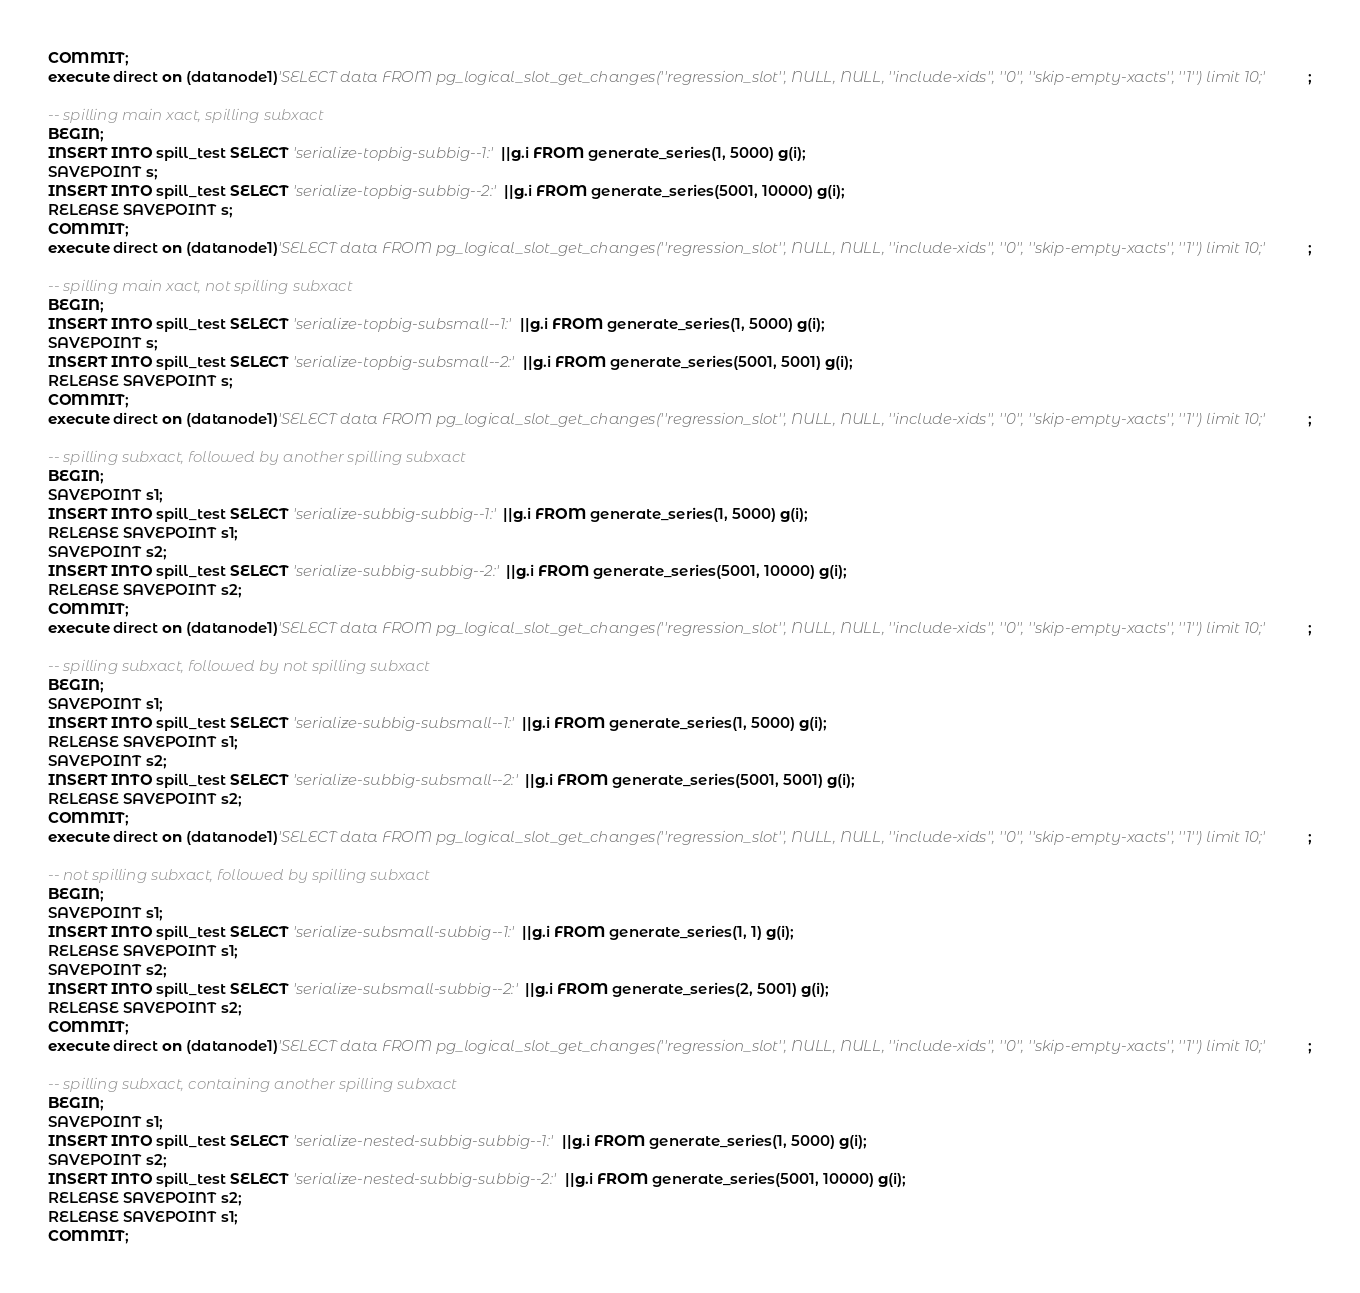Convert code to text. <code><loc_0><loc_0><loc_500><loc_500><_SQL_>COMMIT;
execute direct on (datanode1)'SELECT data FROM pg_logical_slot_get_changes(''regression_slot'', NULL, NULL, ''include-xids'', ''0'', ''skip-empty-xacts'', ''1'') limit 10;';

-- spilling main xact, spilling subxact
BEGIN;
INSERT INTO spill_test SELECT 'serialize-topbig-subbig--1:'||g.i FROM generate_series(1, 5000) g(i);
SAVEPOINT s;
INSERT INTO spill_test SELECT 'serialize-topbig-subbig--2:'||g.i FROM generate_series(5001, 10000) g(i);
RELEASE SAVEPOINT s;
COMMIT;
execute direct on (datanode1)'SELECT data FROM pg_logical_slot_get_changes(''regression_slot'', NULL, NULL, ''include-xids'', ''0'', ''skip-empty-xacts'', ''1'') limit 10;';

-- spilling main xact, not spilling subxact
BEGIN;
INSERT INTO spill_test SELECT 'serialize-topbig-subsmall--1:'||g.i FROM generate_series(1, 5000) g(i);
SAVEPOINT s;
INSERT INTO spill_test SELECT 'serialize-topbig-subsmall--2:'||g.i FROM generate_series(5001, 5001) g(i);
RELEASE SAVEPOINT s;
COMMIT;
execute direct on (datanode1)'SELECT data FROM pg_logical_slot_get_changes(''regression_slot'', NULL, NULL, ''include-xids'', ''0'', ''skip-empty-xacts'', ''1'') limit 10;';

-- spilling subxact, followed by another spilling subxact
BEGIN;
SAVEPOINT s1;
INSERT INTO spill_test SELECT 'serialize-subbig-subbig--1:'||g.i FROM generate_series(1, 5000) g(i);
RELEASE SAVEPOINT s1;
SAVEPOINT s2;
INSERT INTO spill_test SELECT 'serialize-subbig-subbig--2:'||g.i FROM generate_series(5001, 10000) g(i);
RELEASE SAVEPOINT s2;
COMMIT;
execute direct on (datanode1)'SELECT data FROM pg_logical_slot_get_changes(''regression_slot'', NULL, NULL, ''include-xids'', ''0'', ''skip-empty-xacts'', ''1'') limit 10;';

-- spilling subxact, followed by not spilling subxact
BEGIN;
SAVEPOINT s1;
INSERT INTO spill_test SELECT 'serialize-subbig-subsmall--1:'||g.i FROM generate_series(1, 5000) g(i);
RELEASE SAVEPOINT s1;
SAVEPOINT s2;
INSERT INTO spill_test SELECT 'serialize-subbig-subsmall--2:'||g.i FROM generate_series(5001, 5001) g(i);
RELEASE SAVEPOINT s2;
COMMIT;
execute direct on (datanode1)'SELECT data FROM pg_logical_slot_get_changes(''regression_slot'', NULL, NULL, ''include-xids'', ''0'', ''skip-empty-xacts'', ''1'') limit 10;';

-- not spilling subxact, followed by spilling subxact
BEGIN;
SAVEPOINT s1;
INSERT INTO spill_test SELECT 'serialize-subsmall-subbig--1:'||g.i FROM generate_series(1, 1) g(i);
RELEASE SAVEPOINT s1;
SAVEPOINT s2;
INSERT INTO spill_test SELECT 'serialize-subsmall-subbig--2:'||g.i FROM generate_series(2, 5001) g(i);
RELEASE SAVEPOINT s2;
COMMIT;
execute direct on (datanode1)'SELECT data FROM pg_logical_slot_get_changes(''regression_slot'', NULL, NULL, ''include-xids'', ''0'', ''skip-empty-xacts'', ''1'') limit 10;';

-- spilling subxact, containing another spilling subxact
BEGIN;
SAVEPOINT s1;
INSERT INTO spill_test SELECT 'serialize-nested-subbig-subbig--1:'||g.i FROM generate_series(1, 5000) g(i);
SAVEPOINT s2;
INSERT INTO spill_test SELECT 'serialize-nested-subbig-subbig--2:'||g.i FROM generate_series(5001, 10000) g(i);
RELEASE SAVEPOINT s2;
RELEASE SAVEPOINT s1;
COMMIT;</code> 